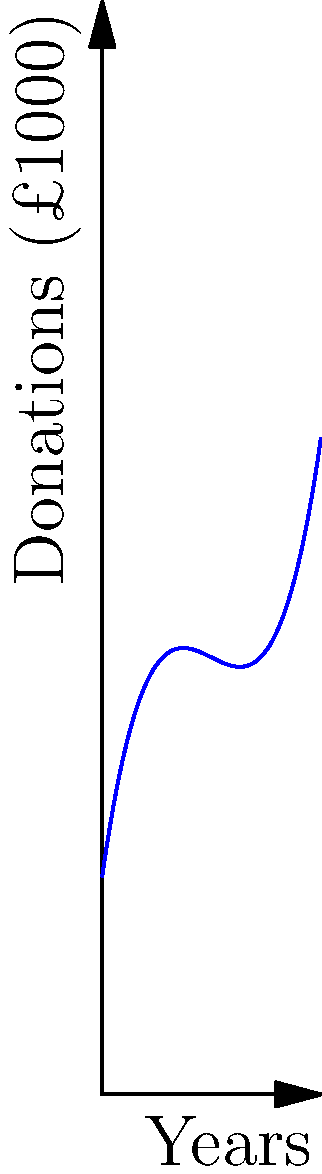A local charity's donation growth over a decade is represented by the polynomial curve above, where the x-axis shows years and the y-axis shows donations in thousands of pounds. At which point does the charity experience the slowest growth rate in donations? To determine the point of slowest growth, we need to analyze the curve's slope:

1. The slope of the curve represents the rate of change in donations.
2. The point with the least steep slope is where the growth rate is slowest.
3. Examining the curve:
   - From A to B, the slope starts steep and gradually decreases.
   - Around point B, the curve is nearly flat, indicating the slowest growth.
   - From B to C, the slope increases again, showing faster growth.
4. Therefore, the slowest growth rate occurs at point B, which is approximately 5 years into the decade.

This analysis doesn't require complex calculations, just an understanding of how slope relates to growth rate on a graph.
Answer: Point B (around 5 years) 